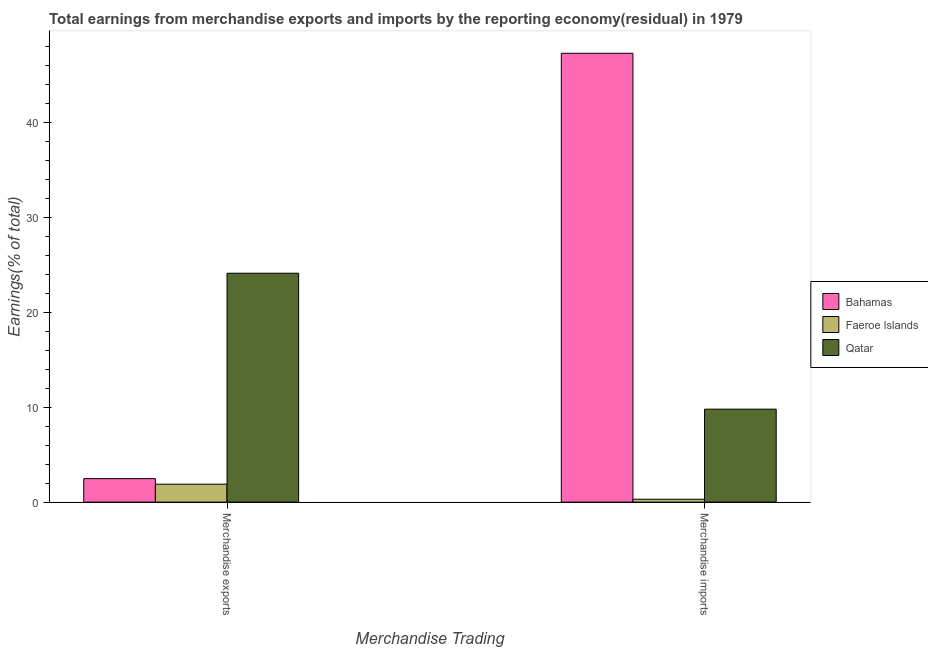How many different coloured bars are there?
Your answer should be compact. 3. How many groups of bars are there?
Provide a short and direct response. 2. What is the earnings from merchandise exports in Bahamas?
Provide a short and direct response. 2.48. Across all countries, what is the maximum earnings from merchandise exports?
Make the answer very short. 24.14. Across all countries, what is the minimum earnings from merchandise exports?
Your answer should be compact. 1.89. In which country was the earnings from merchandise imports maximum?
Make the answer very short. Bahamas. In which country was the earnings from merchandise exports minimum?
Ensure brevity in your answer.  Faeroe Islands. What is the total earnings from merchandise exports in the graph?
Offer a very short reply. 28.51. What is the difference between the earnings from merchandise exports in Bahamas and that in Qatar?
Your answer should be compact. -21.66. What is the difference between the earnings from merchandise exports in Qatar and the earnings from merchandise imports in Bahamas?
Your answer should be compact. -23.19. What is the average earnings from merchandise imports per country?
Keep it short and to the point. 19.15. What is the difference between the earnings from merchandise exports and earnings from merchandise imports in Qatar?
Your answer should be very brief. 14.33. In how many countries, is the earnings from merchandise imports greater than 26 %?
Give a very brief answer. 1. What is the ratio of the earnings from merchandise imports in Bahamas to that in Qatar?
Offer a terse response. 4.83. Is the earnings from merchandise exports in Faeroe Islands less than that in Qatar?
Your response must be concise. Yes. What does the 2nd bar from the left in Merchandise exports represents?
Offer a terse response. Faeroe Islands. What does the 2nd bar from the right in Merchandise exports represents?
Your answer should be very brief. Faeroe Islands. How many countries are there in the graph?
Your answer should be compact. 3. What is the difference between two consecutive major ticks on the Y-axis?
Your response must be concise. 10. Where does the legend appear in the graph?
Offer a terse response. Center right. How many legend labels are there?
Ensure brevity in your answer.  3. What is the title of the graph?
Make the answer very short. Total earnings from merchandise exports and imports by the reporting economy(residual) in 1979. Does "Ukraine" appear as one of the legend labels in the graph?
Your response must be concise. No. What is the label or title of the X-axis?
Keep it short and to the point. Merchandise Trading. What is the label or title of the Y-axis?
Provide a succinct answer. Earnings(% of total). What is the Earnings(% of total) of Bahamas in Merchandise exports?
Give a very brief answer. 2.48. What is the Earnings(% of total) of Faeroe Islands in Merchandise exports?
Keep it short and to the point. 1.89. What is the Earnings(% of total) of Qatar in Merchandise exports?
Offer a terse response. 24.14. What is the Earnings(% of total) of Bahamas in Merchandise imports?
Provide a succinct answer. 47.33. What is the Earnings(% of total) of Faeroe Islands in Merchandise imports?
Provide a succinct answer. 0.31. What is the Earnings(% of total) in Qatar in Merchandise imports?
Keep it short and to the point. 9.8. Across all Merchandise Trading, what is the maximum Earnings(% of total) of Bahamas?
Your response must be concise. 47.33. Across all Merchandise Trading, what is the maximum Earnings(% of total) of Faeroe Islands?
Your response must be concise. 1.89. Across all Merchandise Trading, what is the maximum Earnings(% of total) in Qatar?
Offer a terse response. 24.14. Across all Merchandise Trading, what is the minimum Earnings(% of total) in Bahamas?
Offer a very short reply. 2.48. Across all Merchandise Trading, what is the minimum Earnings(% of total) in Faeroe Islands?
Ensure brevity in your answer.  0.31. Across all Merchandise Trading, what is the minimum Earnings(% of total) in Qatar?
Your answer should be very brief. 9.8. What is the total Earnings(% of total) in Bahamas in the graph?
Your response must be concise. 49.81. What is the total Earnings(% of total) in Faeroe Islands in the graph?
Provide a succinct answer. 2.2. What is the total Earnings(% of total) of Qatar in the graph?
Your answer should be compact. 33.94. What is the difference between the Earnings(% of total) in Bahamas in Merchandise exports and that in Merchandise imports?
Ensure brevity in your answer.  -44.85. What is the difference between the Earnings(% of total) in Faeroe Islands in Merchandise exports and that in Merchandise imports?
Your answer should be compact. 1.59. What is the difference between the Earnings(% of total) in Qatar in Merchandise exports and that in Merchandise imports?
Offer a terse response. 14.33. What is the difference between the Earnings(% of total) in Bahamas in Merchandise exports and the Earnings(% of total) in Faeroe Islands in Merchandise imports?
Offer a terse response. 2.17. What is the difference between the Earnings(% of total) in Bahamas in Merchandise exports and the Earnings(% of total) in Qatar in Merchandise imports?
Give a very brief answer. -7.33. What is the difference between the Earnings(% of total) in Faeroe Islands in Merchandise exports and the Earnings(% of total) in Qatar in Merchandise imports?
Offer a terse response. -7.91. What is the average Earnings(% of total) of Bahamas per Merchandise Trading?
Give a very brief answer. 24.9. What is the average Earnings(% of total) of Faeroe Islands per Merchandise Trading?
Make the answer very short. 1.1. What is the average Earnings(% of total) of Qatar per Merchandise Trading?
Offer a very short reply. 16.97. What is the difference between the Earnings(% of total) in Bahamas and Earnings(% of total) in Faeroe Islands in Merchandise exports?
Your answer should be very brief. 0.59. What is the difference between the Earnings(% of total) in Bahamas and Earnings(% of total) in Qatar in Merchandise exports?
Keep it short and to the point. -21.66. What is the difference between the Earnings(% of total) in Faeroe Islands and Earnings(% of total) in Qatar in Merchandise exports?
Your answer should be compact. -22.24. What is the difference between the Earnings(% of total) in Bahamas and Earnings(% of total) in Faeroe Islands in Merchandise imports?
Give a very brief answer. 47.02. What is the difference between the Earnings(% of total) of Bahamas and Earnings(% of total) of Qatar in Merchandise imports?
Provide a succinct answer. 37.53. What is the difference between the Earnings(% of total) in Faeroe Islands and Earnings(% of total) in Qatar in Merchandise imports?
Provide a short and direct response. -9.5. What is the ratio of the Earnings(% of total) of Bahamas in Merchandise exports to that in Merchandise imports?
Give a very brief answer. 0.05. What is the ratio of the Earnings(% of total) of Faeroe Islands in Merchandise exports to that in Merchandise imports?
Keep it short and to the point. 6.2. What is the ratio of the Earnings(% of total) of Qatar in Merchandise exports to that in Merchandise imports?
Make the answer very short. 2.46. What is the difference between the highest and the second highest Earnings(% of total) in Bahamas?
Provide a succinct answer. 44.85. What is the difference between the highest and the second highest Earnings(% of total) of Faeroe Islands?
Ensure brevity in your answer.  1.59. What is the difference between the highest and the second highest Earnings(% of total) in Qatar?
Your answer should be very brief. 14.33. What is the difference between the highest and the lowest Earnings(% of total) of Bahamas?
Give a very brief answer. 44.85. What is the difference between the highest and the lowest Earnings(% of total) in Faeroe Islands?
Offer a terse response. 1.59. What is the difference between the highest and the lowest Earnings(% of total) of Qatar?
Give a very brief answer. 14.33. 